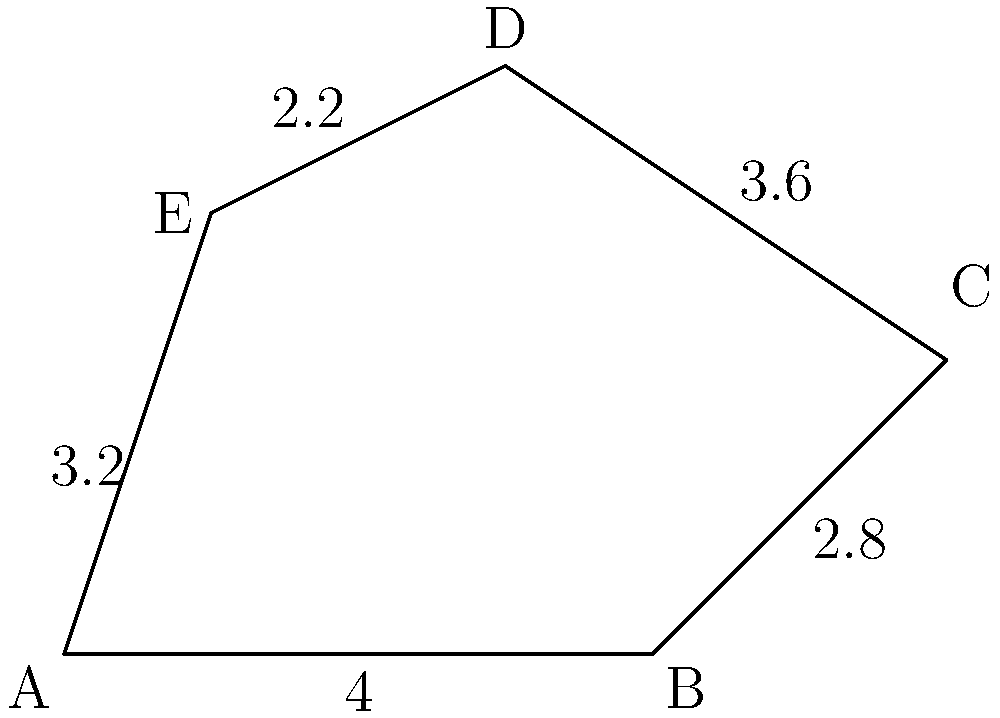The irregular polygon ABCDE represents a map of conflict-affected regions where children's health issues are of particular concern. If the perimeter of this region needs to be secured for humanitarian aid distribution, calculate the total length of the border that needs to be monitored. Use the given measurements in kilometers. To calculate the perimeter of the irregular polygon ABCDE, we need to sum up the lengths of all its sides. Let's go through this step-by-step:

1) Side AB: Given as 4 km
2) Side BC: Given as 2.8 km
3) Side CD: Given as 3.6 km
4) Side DE: Given as 2.2 km
5) Side EA: Given as 3.2 km

Now, let's add all these lengths:

$$\text{Perimeter} = AB + BC + CD + DE + EA$$
$$\text{Perimeter} = 4 + 2.8 + 3.6 + 2.2 + 3.2$$
$$\text{Perimeter} = 15.8 \text{ km}$$

Therefore, the total length of the border that needs to be monitored for humanitarian aid distribution is 15.8 kilometers.
Answer: 15.8 km 